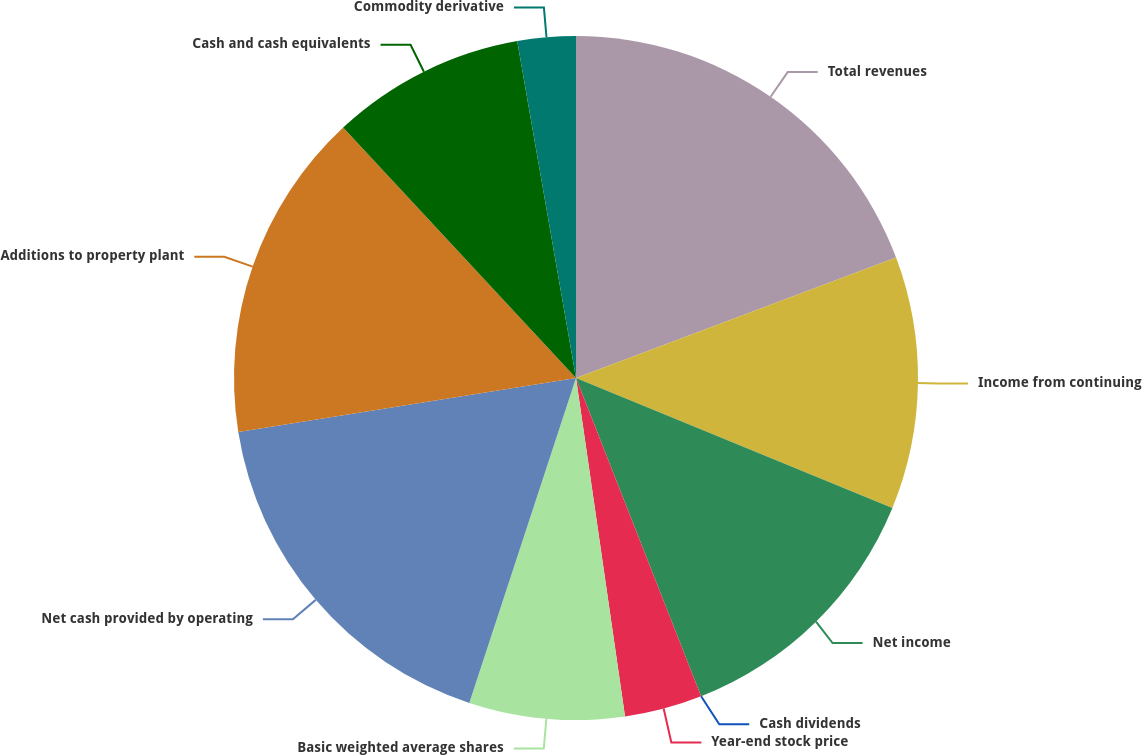<chart> <loc_0><loc_0><loc_500><loc_500><pie_chart><fcel>Total revenues<fcel>Income from continuing<fcel>Net income<fcel>Cash dividends<fcel>Year-end stock price<fcel>Basic weighted average shares<fcel>Net cash provided by operating<fcel>Additions to property plant<fcel>Cash and cash equivalents<fcel>Commodity derivative<nl><fcel>19.27%<fcel>11.93%<fcel>12.84%<fcel>0.0%<fcel>3.67%<fcel>7.34%<fcel>17.43%<fcel>15.6%<fcel>9.17%<fcel>2.75%<nl></chart> 